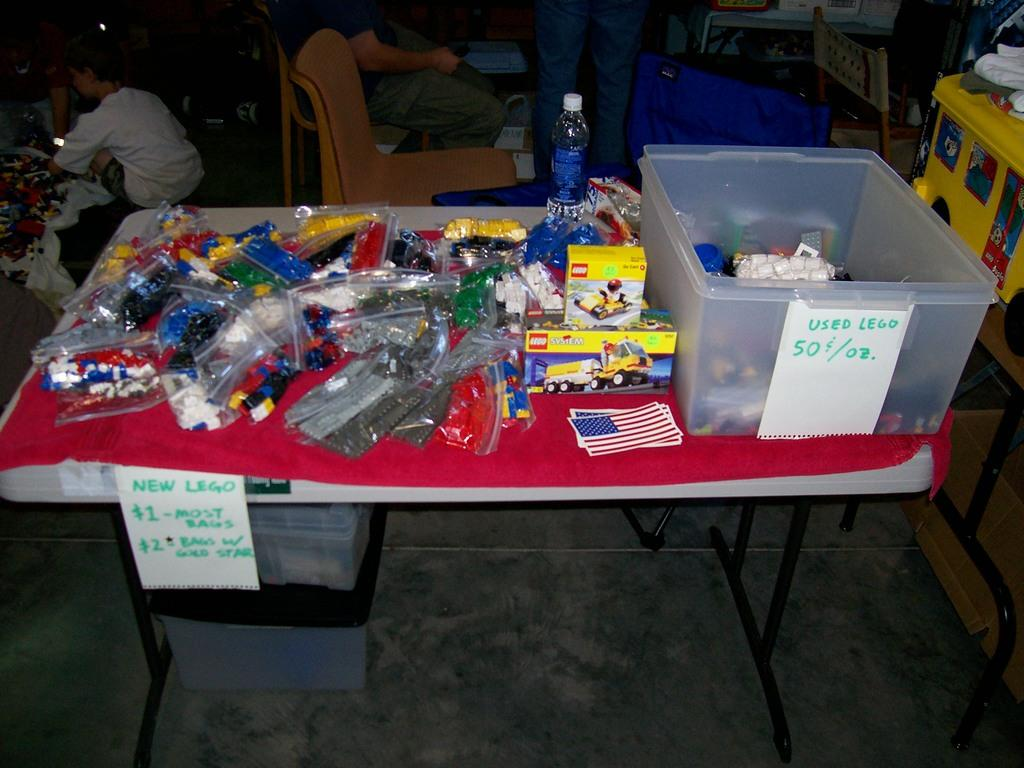What piece of furniture is present in the image? There is a table in the image. What items can be seen on the table? There are packets, boxes, and a bottle on the table. Is there a person in the image? Yes, there is a man sitting on a chair in the image. What part of the room can be seen in the image? The floor is visible in the image. What type of music is the man playing on his camp in the image? There is no camp or music present in the image; it features a man sitting on a chair at a table with various items. 